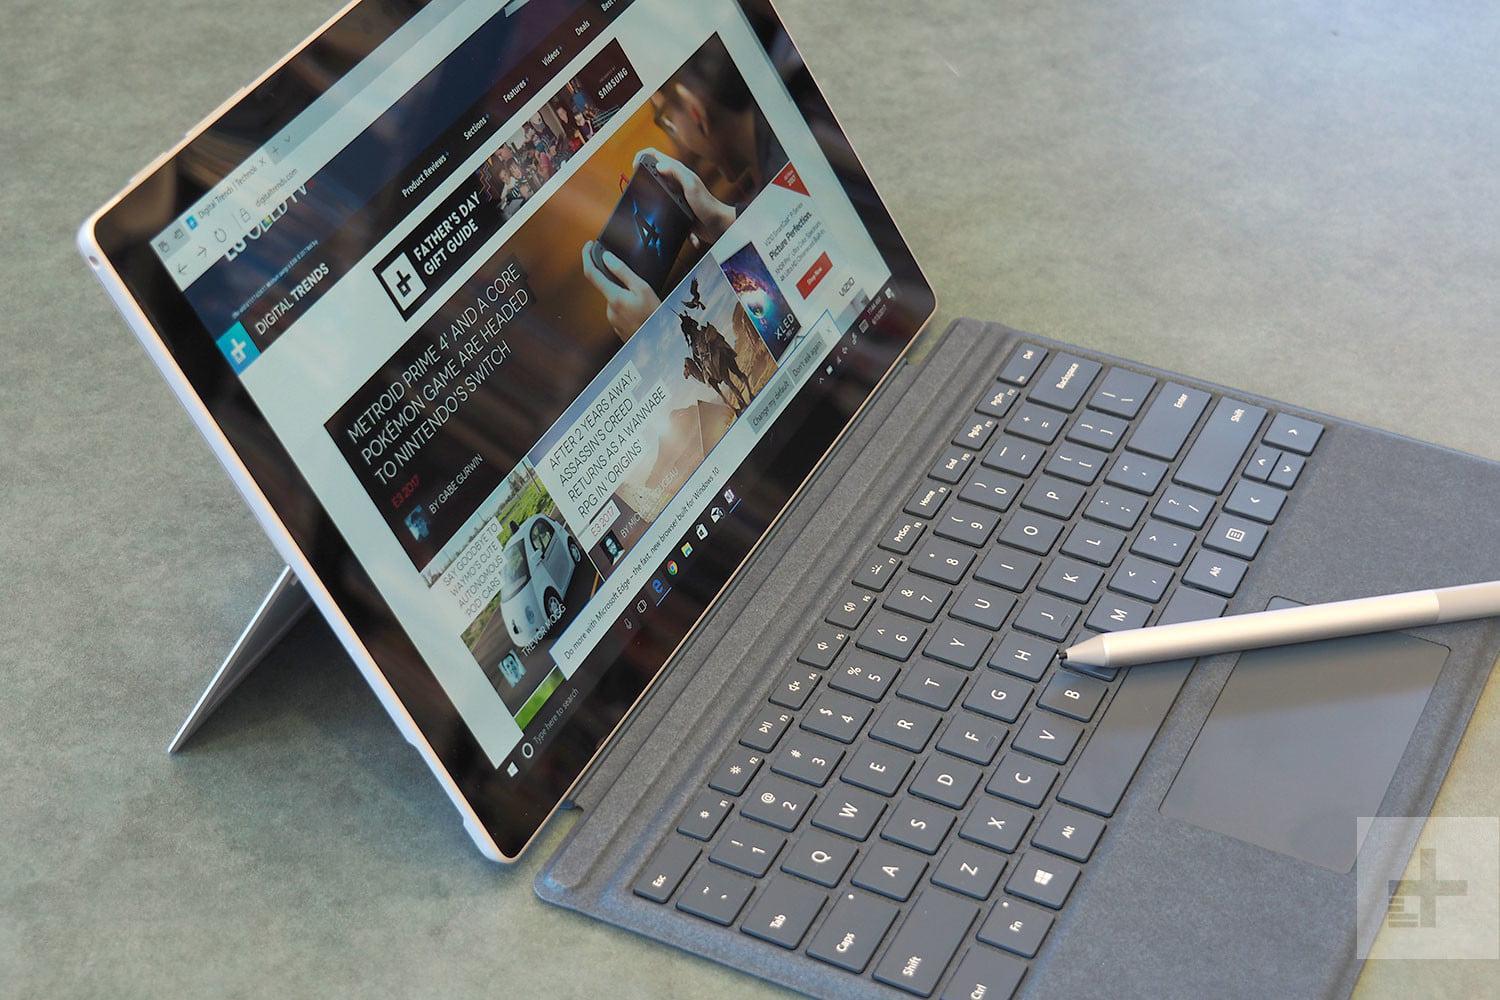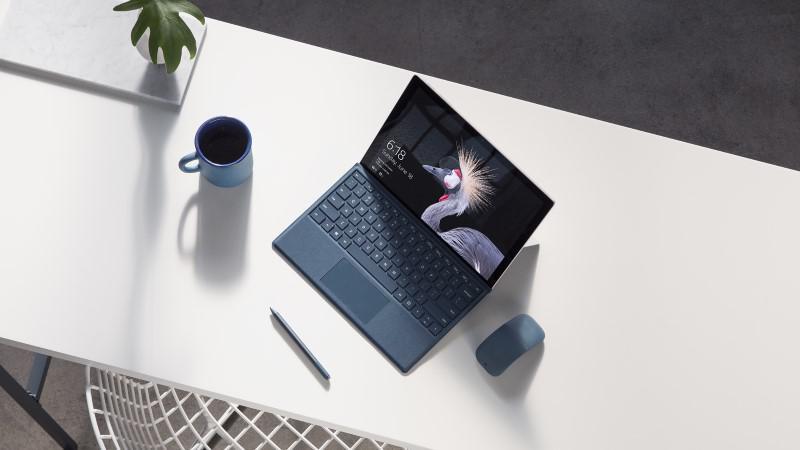The first image is the image on the left, the second image is the image on the right. For the images displayed, is the sentence "there is a stylus on the table next to a laptop" factually correct? Answer yes or no. Yes. The first image is the image on the left, the second image is the image on the right. Evaluate the accuracy of this statement regarding the images: "There are no more than 2 stylus's sitting next to laptops.". Is it true? Answer yes or no. Yes. 